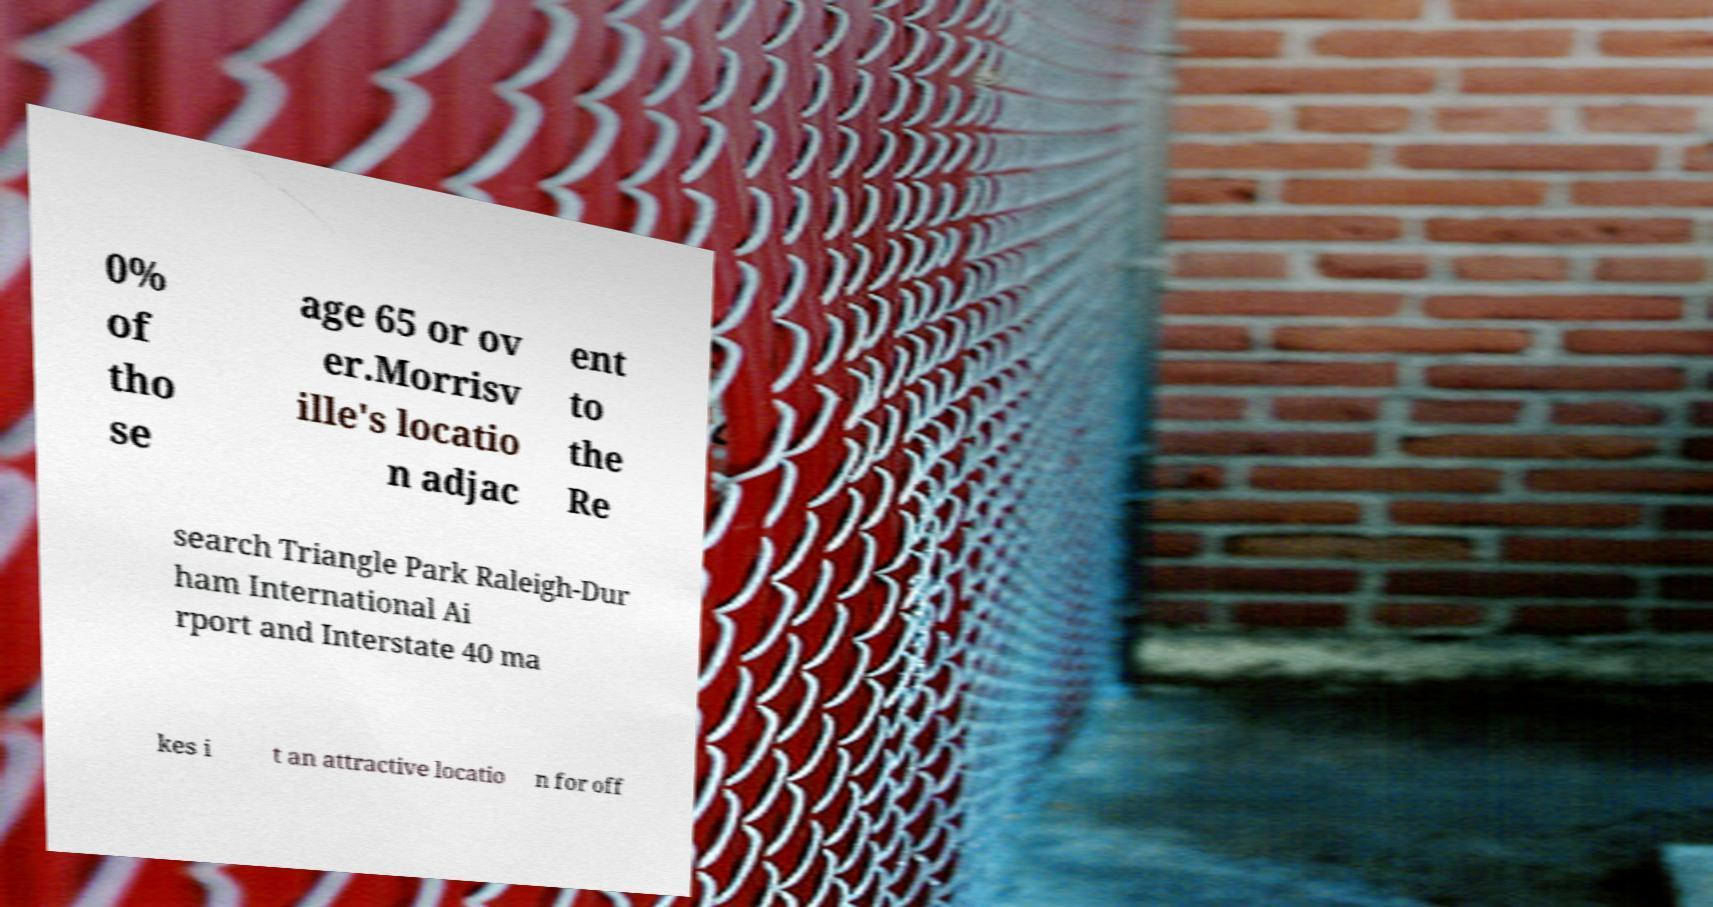Could you assist in decoding the text presented in this image and type it out clearly? 0% of tho se age 65 or ov er.Morrisv ille's locatio n adjac ent to the Re search Triangle Park Raleigh-Dur ham International Ai rport and Interstate 40 ma kes i t an attractive locatio n for off 